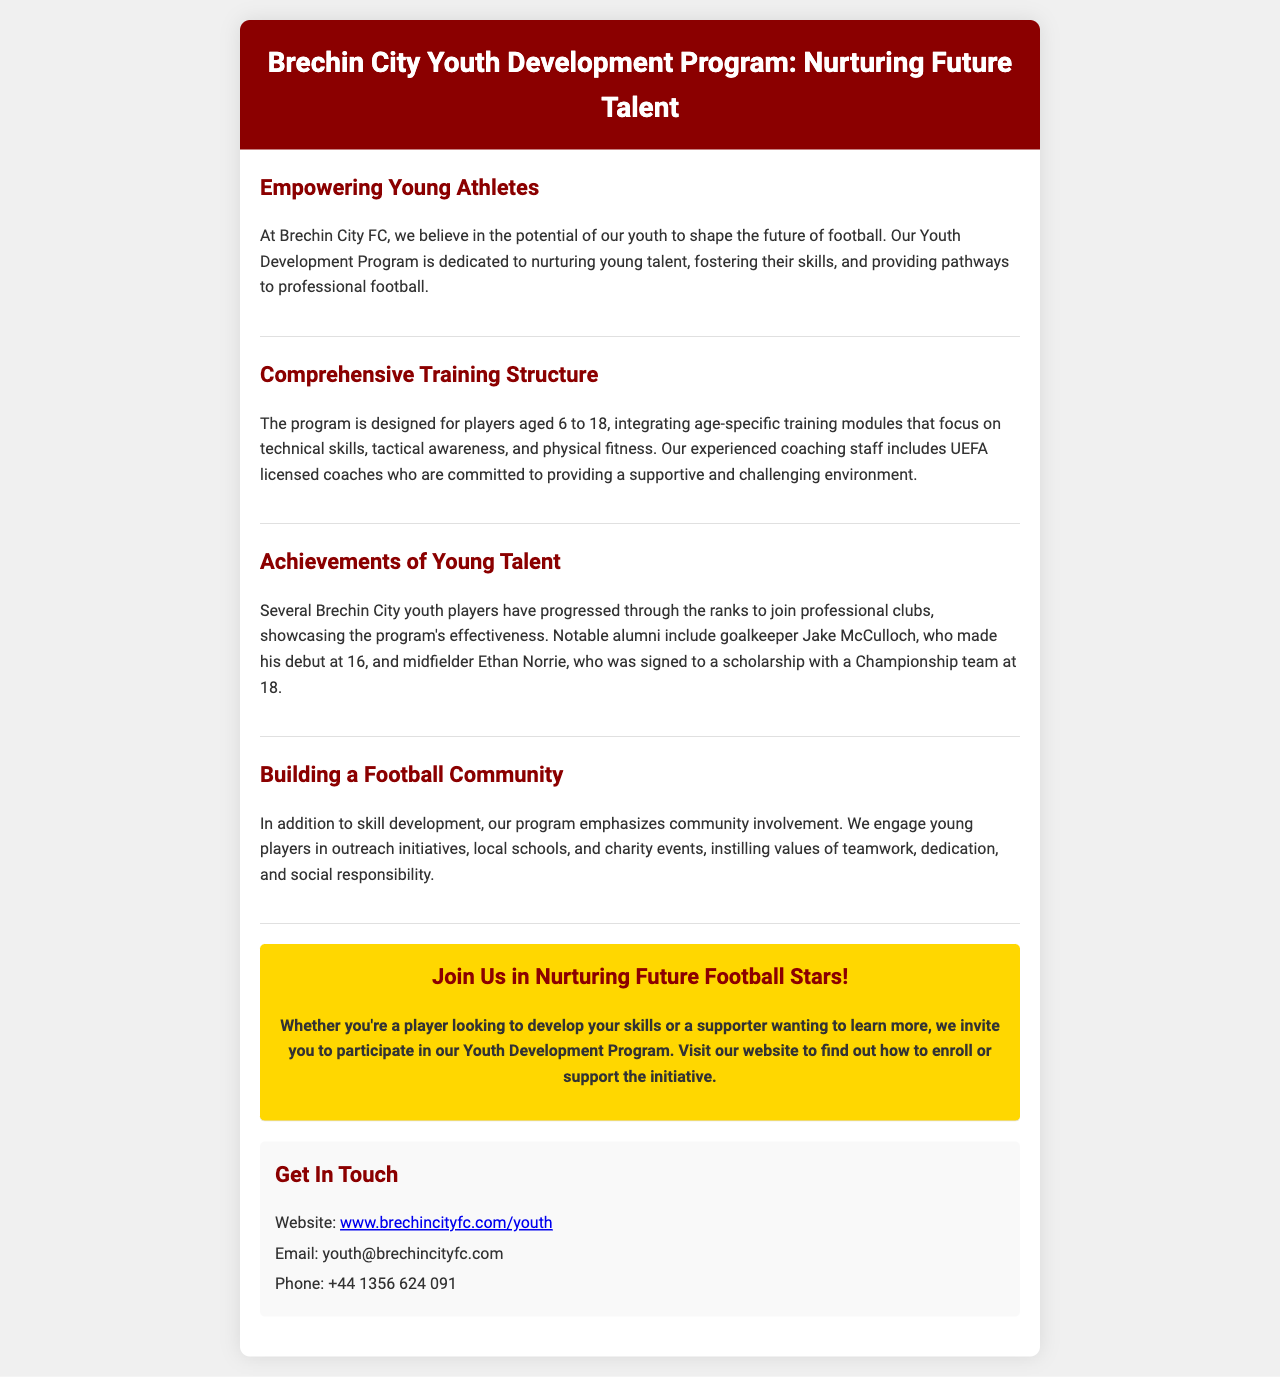What is the age range for the Youth Development Program? The document states that the program is designed for players aged 6 to 18.
Answer: 6 to 18 Who are the coaches in the Youth Development Program? The document mentions that the coaching staff includes UEFA licensed coaches.
Answer: UEFA licensed coaches What notable achievement did goalkeeper Jake McCulloch accomplish? It states that Jake McCulloch made his debut at 16.
Answer: Debut at 16 What values does the program instill in young players? The document mentions that it instills values of teamwork, dedication, and social responsibility.
Answer: Teamwork, dedication, social responsibility How can someone get in touch with the program? The document provides a phone number and email for contact.
Answer: Phone: +44 1356 624 091; Email: youth@brechincityfc.com What is the title of the brochure? The title of the brochure is given in the header section.
Answer: Brechin City Youth Development Program: Nurturing Future Talent How do young players participate in community involvement? The document states they engage in outreach initiatives, local schools, and charity events.
Answer: Outreach initiatives, local schools, charity events 